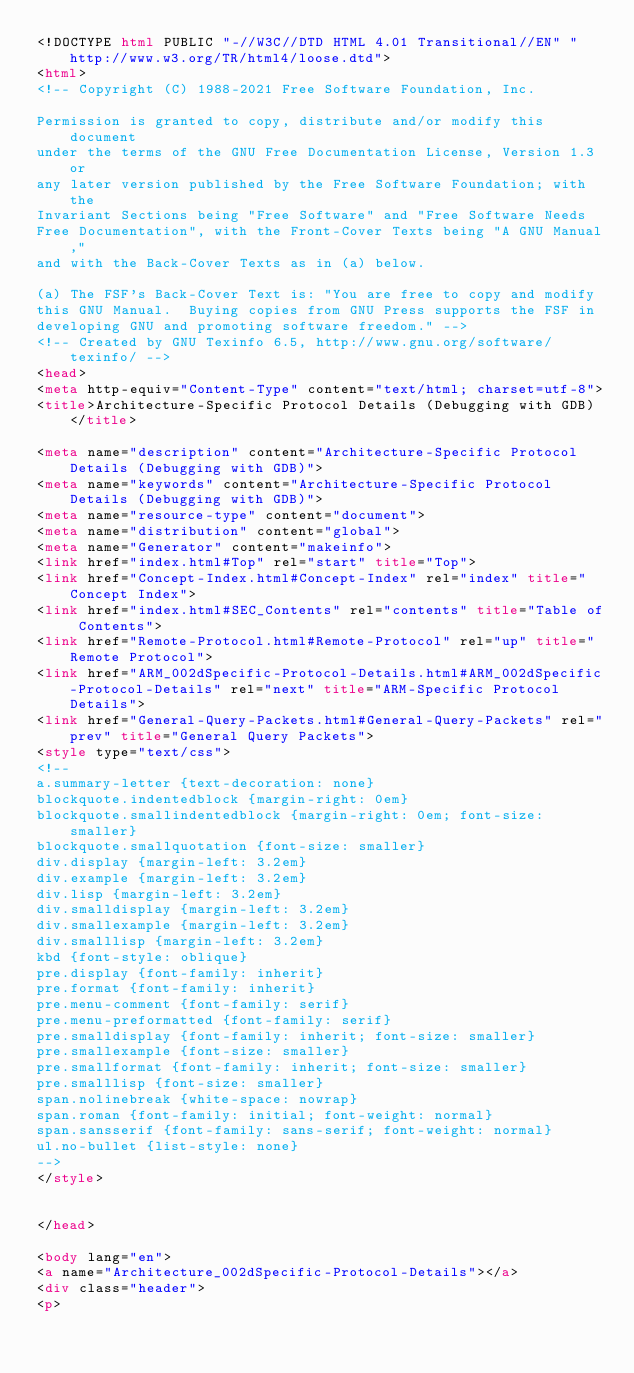<code> <loc_0><loc_0><loc_500><loc_500><_HTML_><!DOCTYPE html PUBLIC "-//W3C//DTD HTML 4.01 Transitional//EN" "http://www.w3.org/TR/html4/loose.dtd">
<html>
<!-- Copyright (C) 1988-2021 Free Software Foundation, Inc.

Permission is granted to copy, distribute and/or modify this document
under the terms of the GNU Free Documentation License, Version 1.3 or
any later version published by the Free Software Foundation; with the
Invariant Sections being "Free Software" and "Free Software Needs
Free Documentation", with the Front-Cover Texts being "A GNU Manual,"
and with the Back-Cover Texts as in (a) below.

(a) The FSF's Back-Cover Text is: "You are free to copy and modify
this GNU Manual.  Buying copies from GNU Press supports the FSF in
developing GNU and promoting software freedom." -->
<!-- Created by GNU Texinfo 6.5, http://www.gnu.org/software/texinfo/ -->
<head>
<meta http-equiv="Content-Type" content="text/html; charset=utf-8">
<title>Architecture-Specific Protocol Details (Debugging with GDB)</title>

<meta name="description" content="Architecture-Specific Protocol Details (Debugging with GDB)">
<meta name="keywords" content="Architecture-Specific Protocol Details (Debugging with GDB)">
<meta name="resource-type" content="document">
<meta name="distribution" content="global">
<meta name="Generator" content="makeinfo">
<link href="index.html#Top" rel="start" title="Top">
<link href="Concept-Index.html#Concept-Index" rel="index" title="Concept Index">
<link href="index.html#SEC_Contents" rel="contents" title="Table of Contents">
<link href="Remote-Protocol.html#Remote-Protocol" rel="up" title="Remote Protocol">
<link href="ARM_002dSpecific-Protocol-Details.html#ARM_002dSpecific-Protocol-Details" rel="next" title="ARM-Specific Protocol Details">
<link href="General-Query-Packets.html#General-Query-Packets" rel="prev" title="General Query Packets">
<style type="text/css">
<!--
a.summary-letter {text-decoration: none}
blockquote.indentedblock {margin-right: 0em}
blockquote.smallindentedblock {margin-right: 0em; font-size: smaller}
blockquote.smallquotation {font-size: smaller}
div.display {margin-left: 3.2em}
div.example {margin-left: 3.2em}
div.lisp {margin-left: 3.2em}
div.smalldisplay {margin-left: 3.2em}
div.smallexample {margin-left: 3.2em}
div.smalllisp {margin-left: 3.2em}
kbd {font-style: oblique}
pre.display {font-family: inherit}
pre.format {font-family: inherit}
pre.menu-comment {font-family: serif}
pre.menu-preformatted {font-family: serif}
pre.smalldisplay {font-family: inherit; font-size: smaller}
pre.smallexample {font-size: smaller}
pre.smallformat {font-family: inherit; font-size: smaller}
pre.smalllisp {font-size: smaller}
span.nolinebreak {white-space: nowrap}
span.roman {font-family: initial; font-weight: normal}
span.sansserif {font-family: sans-serif; font-weight: normal}
ul.no-bullet {list-style: none}
-->
</style>


</head>

<body lang="en">
<a name="Architecture_002dSpecific-Protocol-Details"></a>
<div class="header">
<p></code> 